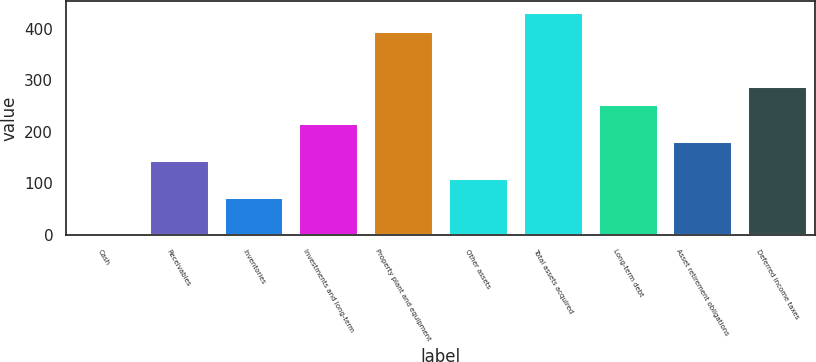Convert chart to OTSL. <chart><loc_0><loc_0><loc_500><loc_500><bar_chart><fcel>Cash<fcel>Receivables<fcel>Inventories<fcel>Investments and long-term<fcel>Property plant and equipment<fcel>Other assets<fcel>Total assets acquired<fcel>Long-term debt<fcel>Asset retirement obligations<fcel>Deferred income taxes<nl><fcel>2<fcel>145.6<fcel>73.8<fcel>217.4<fcel>396.9<fcel>109.7<fcel>432.8<fcel>253.3<fcel>181.5<fcel>289.2<nl></chart> 